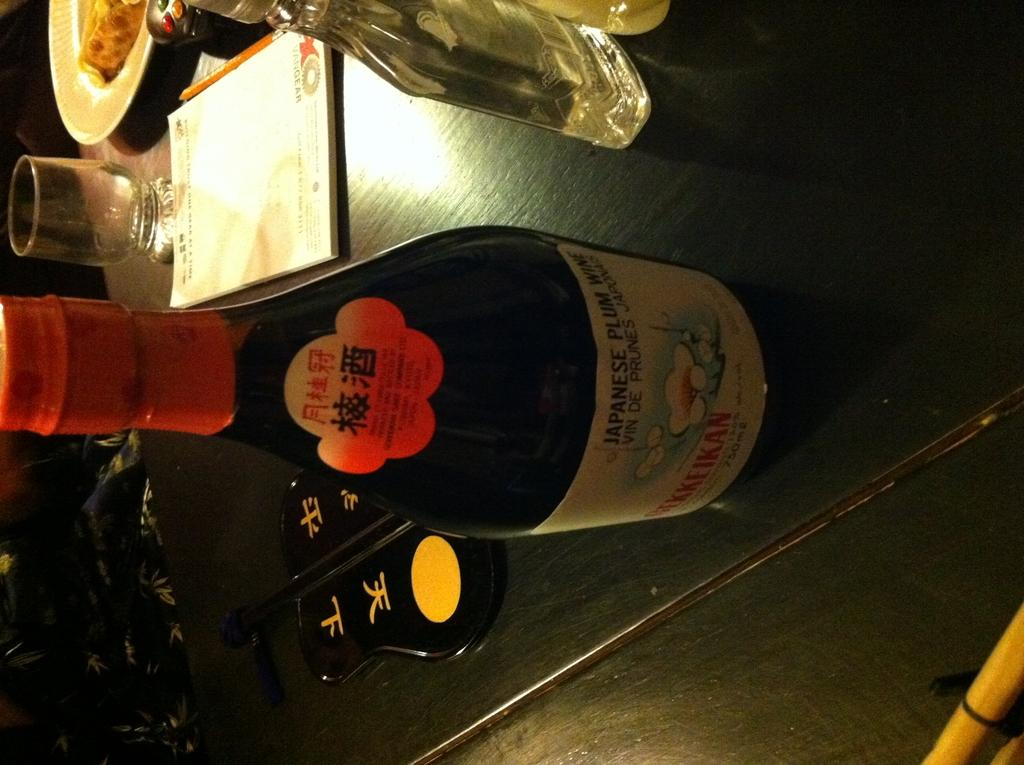What type of bottles are on the table in the image? There is a black bottle and a transparent glass bottle on the table. What is located behind the bottles on the table? There is a book behind the bottles. What is placed behind the book in the image? There is a pencil behind the book. What is positioned behind the pencil in the image? There is a plate behind the pencil. What type of committee is meeting in the image? There is no committee meeting in the image; it only shows bottles, a book, a pencil, and a plate on a table. 